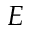Convert formula to latex. <formula><loc_0><loc_0><loc_500><loc_500>E</formula> 